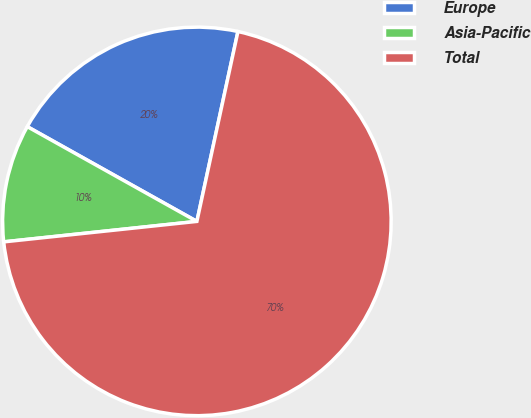<chart> <loc_0><loc_0><loc_500><loc_500><pie_chart><fcel>Europe<fcel>Asia-Pacific<fcel>Total<nl><fcel>20.28%<fcel>9.79%<fcel>69.93%<nl></chart> 